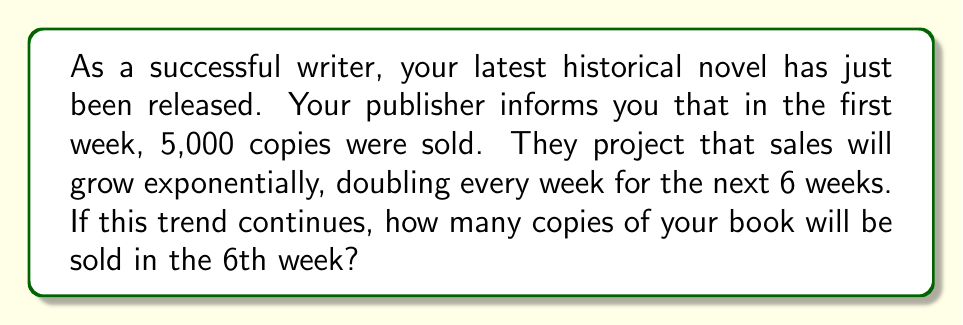Teach me how to tackle this problem. Let's approach this step-by-step:

1) We start with 5,000 copies in the first week.

2) The sales double every week, which means we're dealing with exponential growth with a base of 2.

3) We want to know the sales in the 6th week, which means we need to calculate 5 doublings from the initial amount.

4) We can express this mathematically as:

   $$ \text{Sales in 6th week} = 5000 \cdot 2^5 $$

5) Let's calculate $2^5$:
   $$ 2^5 = 2 \cdot 2 \cdot 2 \cdot 2 \cdot 2 = 32 $$

6) Now we can multiply:
   $$ 5000 \cdot 32 = 160,000 $$

Therefore, in the 6th week, 160,000 copies of your book will be sold if the exponential growth trend continues.
Answer: 160,000 copies 